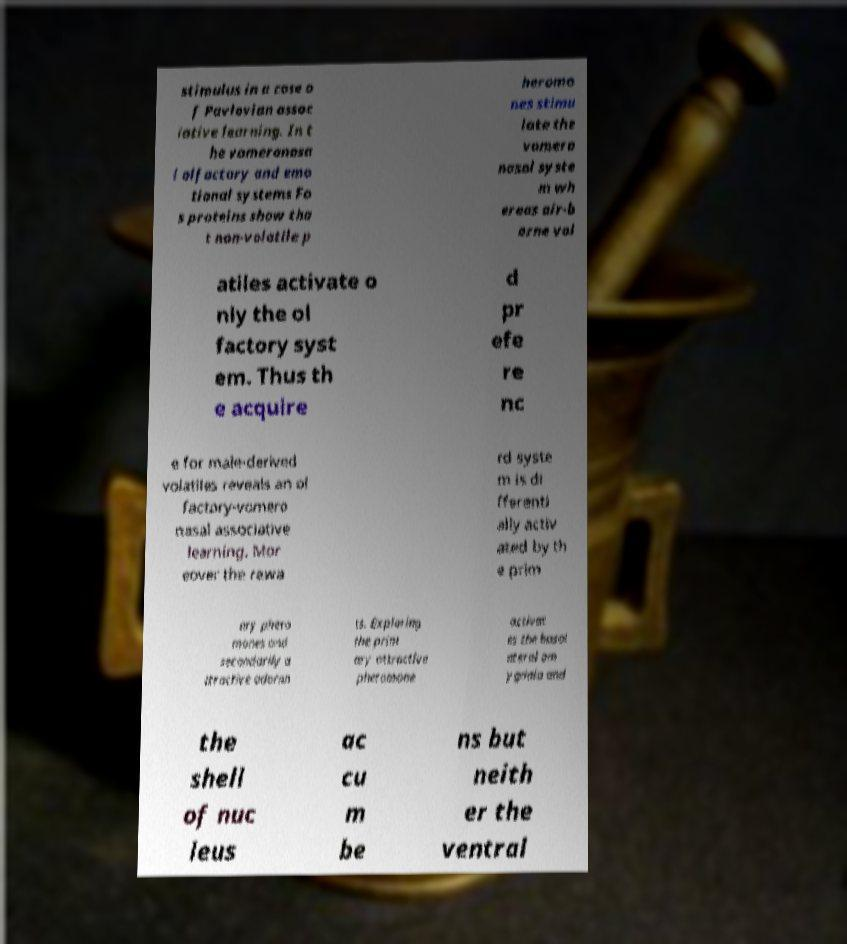Can you read and provide the text displayed in the image?This photo seems to have some interesting text. Can you extract and type it out for me? stimulus in a case o f Pavlovian assoc iative learning. In t he vomeronasa l olfactory and emo tional systems Fo s proteins show tha t non-volatile p heromo nes stimu late the vomero nasal syste m wh ereas air-b orne vol atiles activate o nly the ol factory syst em. Thus th e acquire d pr efe re nc e for male-derived volatiles reveals an ol factory-vomero nasal associative learning. Mor eover the rewa rd syste m is di fferenti ally activ ated by th e prim ary phero mones and secondarily a ttractive odoran ts. Exploring the prim ary attractive pheromone activat es the basol ateral am ygdala and the shell of nuc leus ac cu m be ns but neith er the ventral 